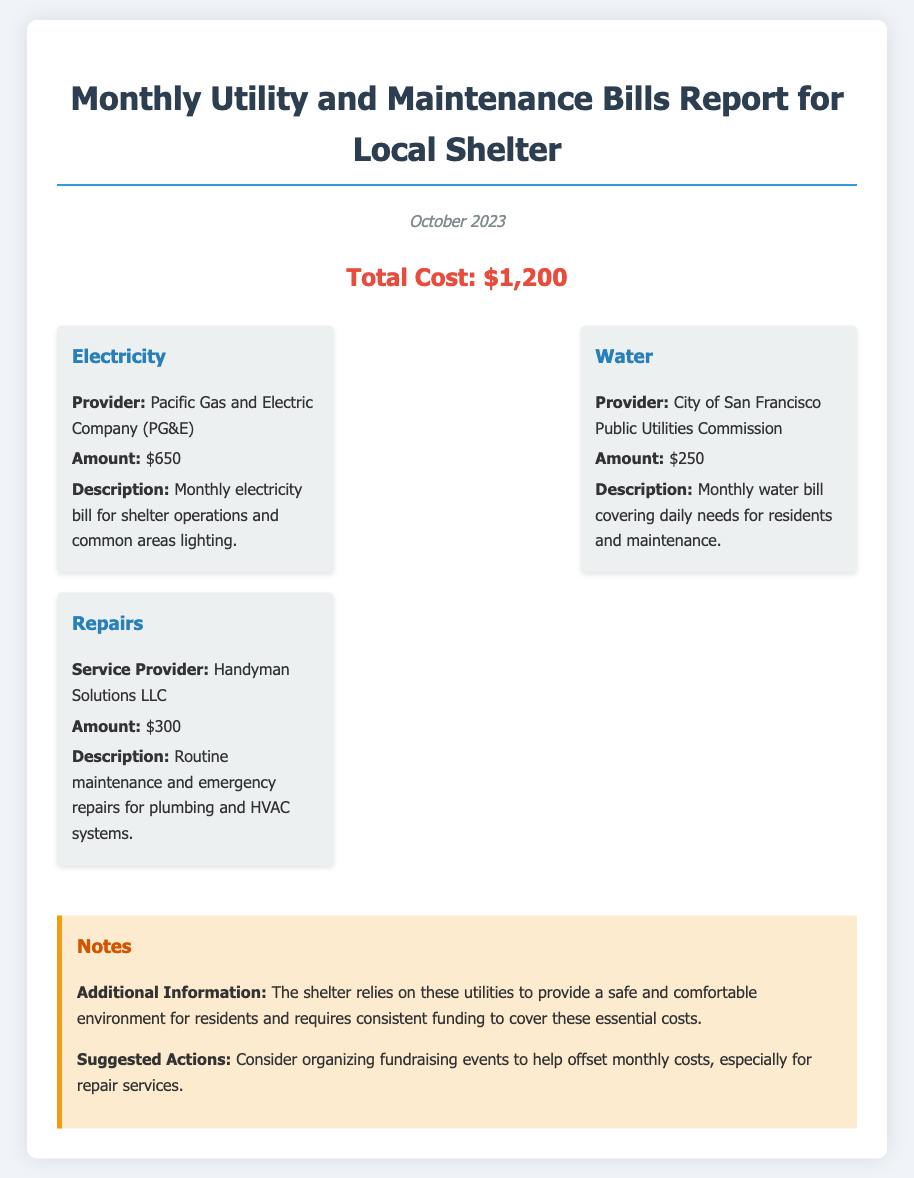What is the total cost? The total cost is stated clearly in the document as the overall expense for October 2023, which is $1,200.
Answer: $1,200 What is the electricity amount? The amount for electricity is specified under the Electricity cost item, which is $650.
Answer: $650 Who is the provider for water? The provider for water is mentioned in the Water cost item as the City of San Francisco Public Utilities Commission.
Answer: City of San Francisco Public Utilities Commission What amount is spent on repairs? The amount spent on repairs is detailed in the Repairs cost item, which is $300.
Answer: $300 What is the description for electricity? The description for electricity is provided in the Electricity cost item, stating it covers monthly electricity bill for shelter operations and common areas lighting.
Answer: Monthly electricity bill for shelter operations and common areas lighting How much is the water bill? The water bill is listed as the amount under the Water cost item, which is $250.
Answer: $250 What service provider is used for repairs? The service provider for repairs is specified under the Repairs cost item as Handyman Solutions LLC.
Answer: Handyman Solutions LLC What is the suggested action mentioned in the notes? The suggested action refers to organizing fundraising events to help offset monthly costs, particularly for repair services.
Answer: Organizing fundraising events 